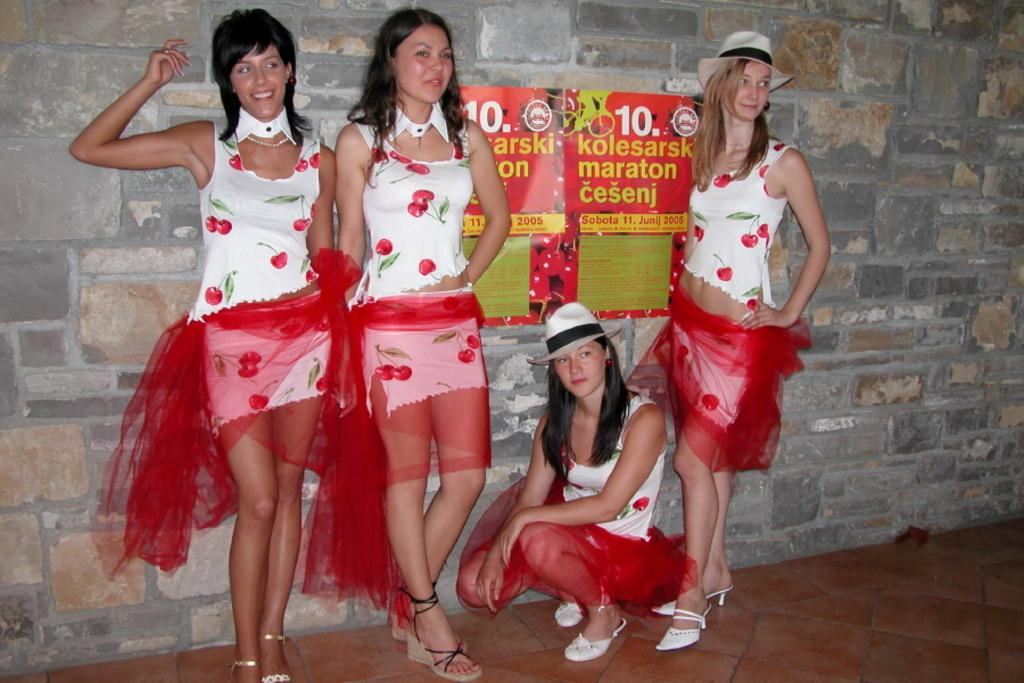How many ladies are in the image? There are four ladies in the image. What are the ladies doing in the image? Three ladies are standing and smiling in the center of the image, while another lady is sitting at the bottom of the image. What can be seen on the wall in the image? There is a board placed on the wall in the image. What type of books can be seen on the trail in the image? There is no trail or books present in the image. 